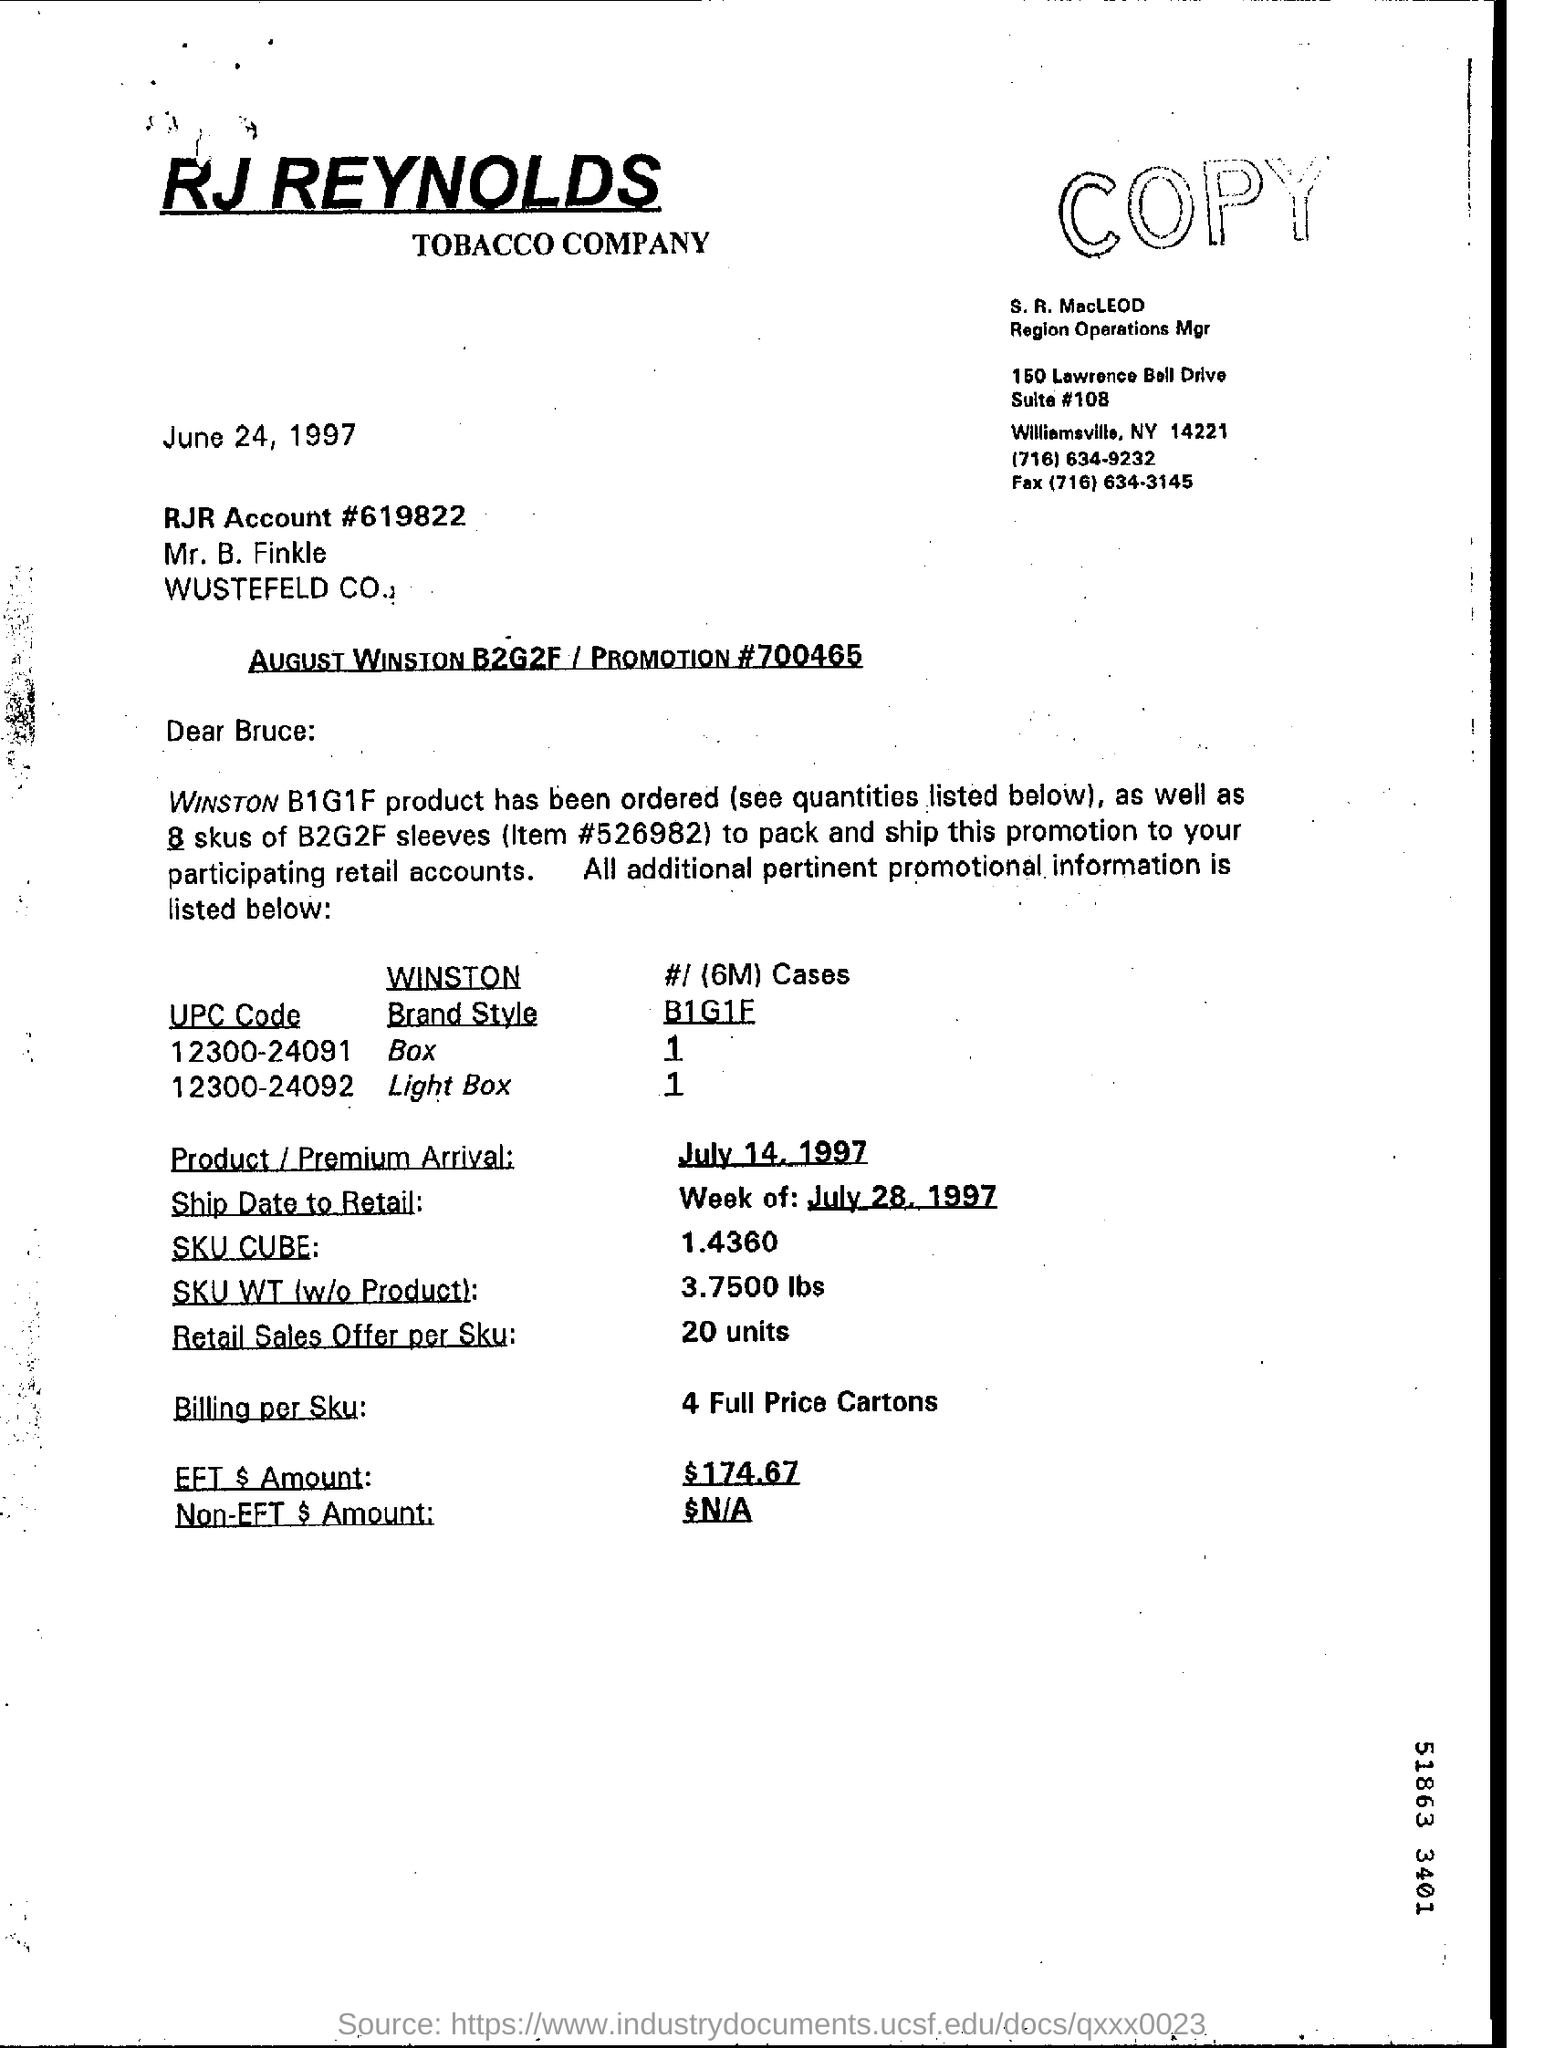What is the date mentioned in the document?
Your answer should be compact. June 24, 1997. What is the RJR Account # number?
Your answer should be very brief. 619822. What is the Brand Style of UPC Code 12300-24092?
Offer a very short reply. Light Box. 